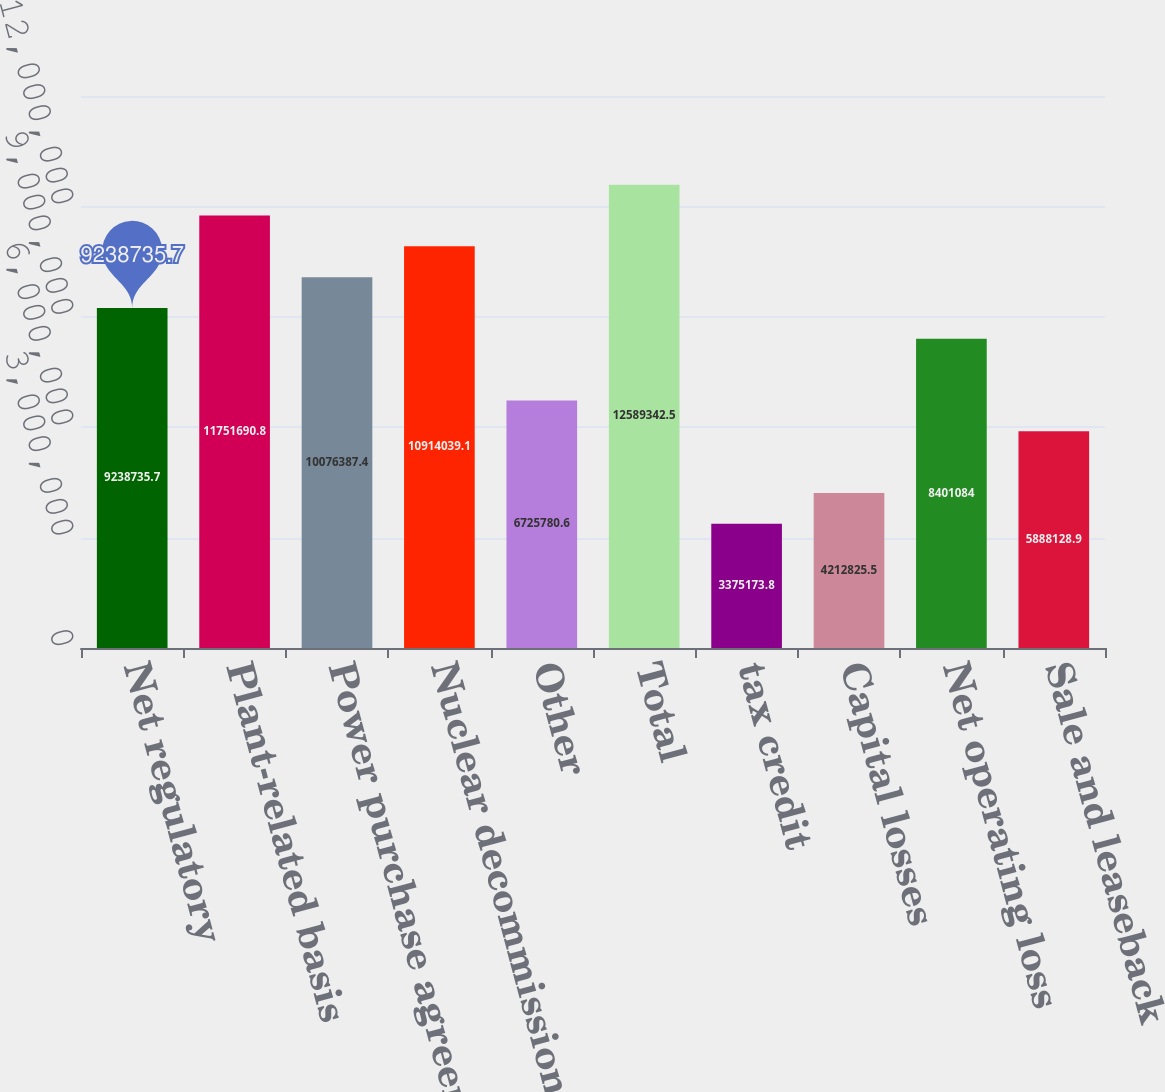<chart> <loc_0><loc_0><loc_500><loc_500><bar_chart><fcel>Net regulatory<fcel>Plant-related basis<fcel>Power purchase agreements<fcel>Nuclear decommissioning trusts<fcel>Other<fcel>Total<fcel>tax credit<fcel>Capital losses<fcel>Net operating loss<fcel>Sale and leaseback<nl><fcel>9.23874e+06<fcel>1.17517e+07<fcel>1.00764e+07<fcel>1.0914e+07<fcel>6.72578e+06<fcel>1.25893e+07<fcel>3.37517e+06<fcel>4.21283e+06<fcel>8.40108e+06<fcel>5.88813e+06<nl></chart> 